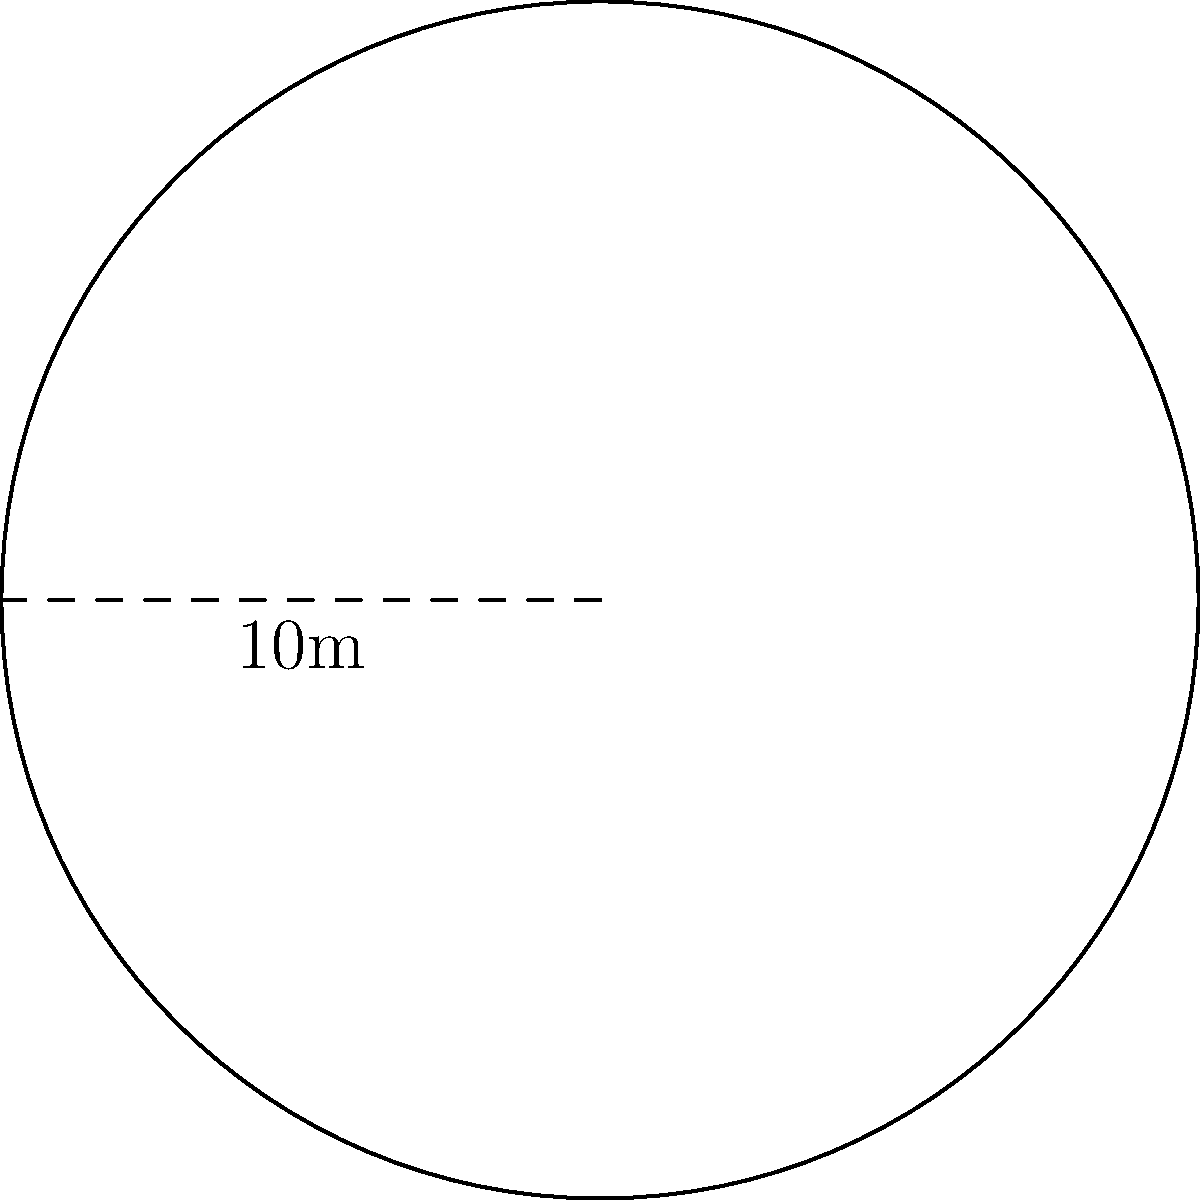Yo, check it out! We're organizing a breakdancing battle on a circular stage. The diameter of this fly circle is 10 meters. What's the total area of the stage where our b-boys and b-girls will be throwing down their illest moves? Alright, let's break this down step by step:

1) First, we need to recognize that we're dealing with a circle. The formula for the area of a circle is:

   $$A = \pi r^2$$

   Where $A$ is the area and $r$ is the radius.

2) We're given the diameter, which is 10 meters. The radius is half of the diameter:

   $$r = \frac{diameter}{2} = \frac{10}{2} = 5\text{ meters}$$

3) Now we can plug this into our formula:

   $$A = \pi (5)^2$$

4) Let's calculate:

   $$A = \pi \cdot 25 = 78.54\text{ square meters}$$

5) Keeping it real, we'll round to two decimal places.

So, our b-boys and b-girls will have 78.54 square meters to showcase their skills and keep the true spirit of hip hop alive!
Answer: $78.54\text{ m}^2$ 